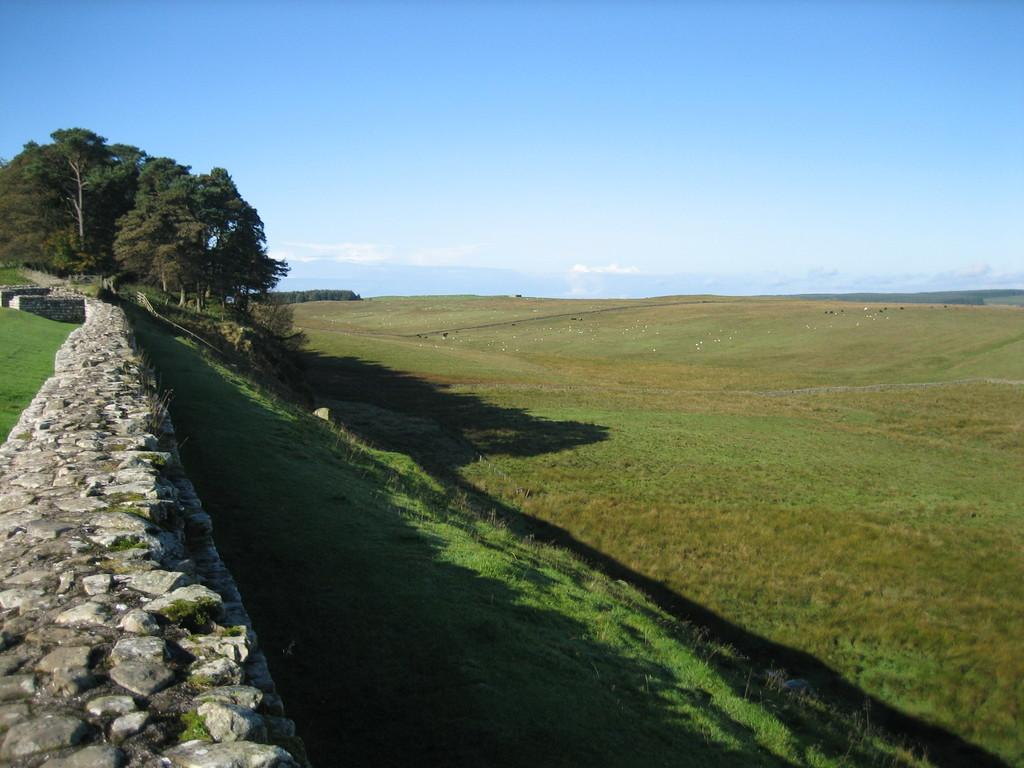What type of vegetation can be seen in the image? There are trees in the image. What is located on the left side of the image? There is a wall on the left side of the image. What is visible at the top of the image? The sky is visible at the top of the image. What can be seen in the sky? There are clouds in the sky. What type of ground surface is present at the bottom of the image? Grass is present at the bottom of the image. What type of apparel is the mom wearing in the image? There is no reference to apparel or a mom in the image. 